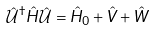Convert formula to latex. <formula><loc_0><loc_0><loc_500><loc_500>\hat { \mathcal { U } } ^ { \dagger } \hat { H } \hat { \mathcal { U } } = \hat { H } _ { 0 } + \hat { V } + \hat { W }</formula> 